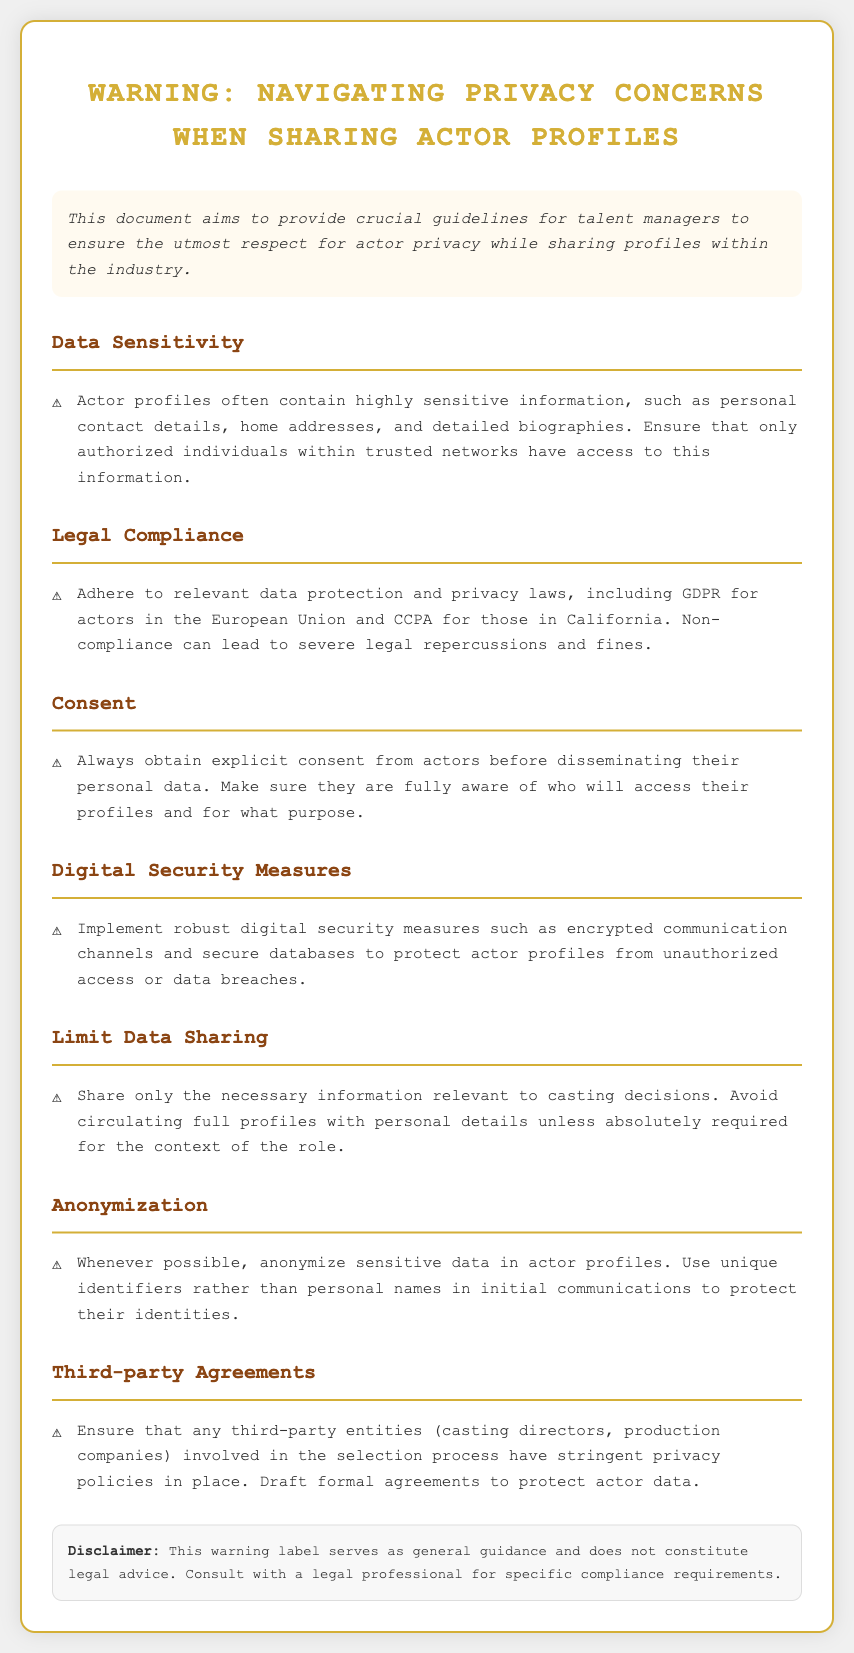What is the main purpose of this document? The main purpose of the document is to provide crucial guidelines for talent managers to ensure respect for actor privacy when sharing profiles.
Answer: Provide crucial guidelines for talent managers What does GDPR stand for? GDPR stands for General Data Protection Regulation, which is relevant for actors in the European Union.
Answer: General Data Protection Regulation What is required before sharing an actor's personal data? Explicit consent from actors is required before disseminating their personal data.
Answer: Explicit consent What should be implemented to protect actor profiles? Robust digital security measures should be implemented to protect actor profiles from unauthorized access.
Answer: Robust digital security measures Which section discusses the necessity of third-party agreements? The section titled "Third-party Agreements" discusses the necessity of such agreements.
Answer: Third-party Agreements What type of information should be shared with third parties? Only necessary information relevant to casting decisions should be shared.
Answer: Necessary information relevant to casting decisions What is a recommended practice for handling sensitive data? Anonymizing sensitive data in actor profiles is a recommended practice.
Answer: Anonymizing sensitive data What is the color scheme of the document's title? The title uses a gold color scheme.
Answer: Gold What does the disclaimer state? The disclaimer states that the warning label serves as general guidance and does not constitute legal advice.
Answer: General guidance and does not constitute legal advice 